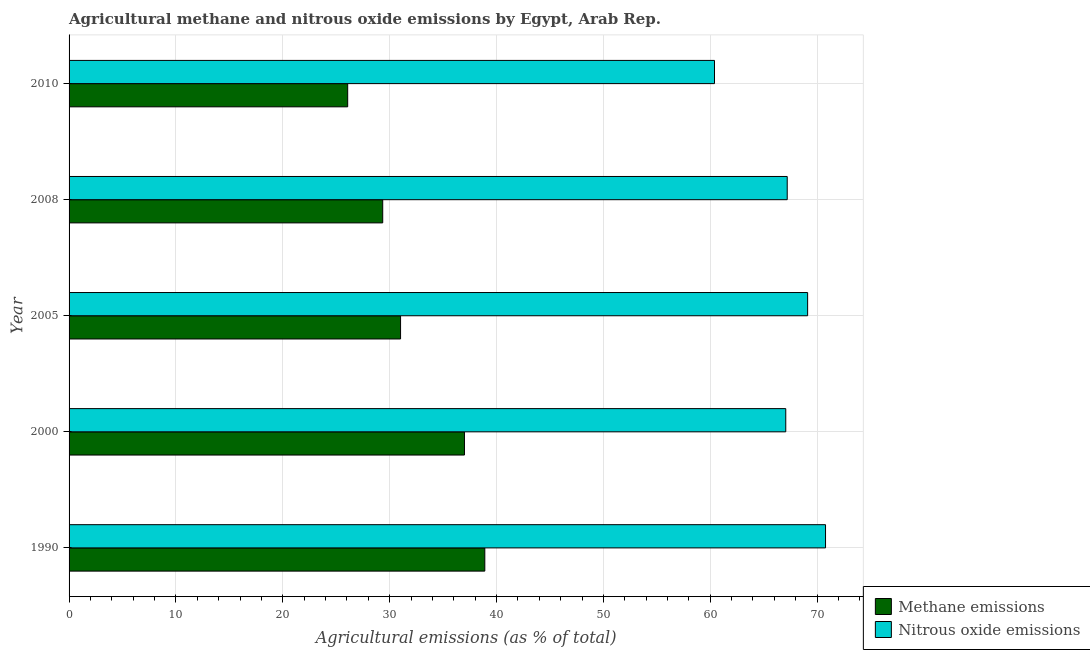How many bars are there on the 3rd tick from the top?
Give a very brief answer. 2. How many bars are there on the 5th tick from the bottom?
Provide a short and direct response. 2. What is the label of the 4th group of bars from the top?
Make the answer very short. 2000. In how many cases, is the number of bars for a given year not equal to the number of legend labels?
Your answer should be very brief. 0. What is the amount of methane emissions in 2000?
Offer a very short reply. 37. Across all years, what is the maximum amount of nitrous oxide emissions?
Ensure brevity in your answer.  70.79. Across all years, what is the minimum amount of methane emissions?
Your answer should be compact. 26.07. What is the total amount of nitrous oxide emissions in the graph?
Offer a terse response. 334.57. What is the difference between the amount of methane emissions in 2000 and that in 2005?
Your answer should be compact. 5.98. What is the difference between the amount of methane emissions in 2008 and the amount of nitrous oxide emissions in 1990?
Give a very brief answer. -41.44. What is the average amount of methane emissions per year?
Give a very brief answer. 32.47. In the year 1990, what is the difference between the amount of nitrous oxide emissions and amount of methane emissions?
Your response must be concise. 31.88. In how many years, is the amount of nitrous oxide emissions greater than 60 %?
Your answer should be compact. 5. Is the amount of nitrous oxide emissions in 2000 less than that in 2008?
Your answer should be very brief. Yes. Is the difference between the amount of nitrous oxide emissions in 2000 and 2005 greater than the difference between the amount of methane emissions in 2000 and 2005?
Your response must be concise. No. What is the difference between the highest and the second highest amount of nitrous oxide emissions?
Your response must be concise. 1.68. What is the difference between the highest and the lowest amount of methane emissions?
Keep it short and to the point. 12.83. What does the 2nd bar from the top in 1990 represents?
Provide a short and direct response. Methane emissions. What does the 1st bar from the bottom in 2000 represents?
Offer a very short reply. Methane emissions. How many bars are there?
Your response must be concise. 10. How many years are there in the graph?
Keep it short and to the point. 5. What is the difference between two consecutive major ticks on the X-axis?
Your response must be concise. 10. Are the values on the major ticks of X-axis written in scientific E-notation?
Offer a very short reply. No. How many legend labels are there?
Provide a short and direct response. 2. What is the title of the graph?
Offer a very short reply. Agricultural methane and nitrous oxide emissions by Egypt, Arab Rep. What is the label or title of the X-axis?
Your response must be concise. Agricultural emissions (as % of total). What is the label or title of the Y-axis?
Ensure brevity in your answer.  Year. What is the Agricultural emissions (as % of total) in Methane emissions in 1990?
Your answer should be compact. 38.9. What is the Agricultural emissions (as % of total) of Nitrous oxide emissions in 1990?
Provide a short and direct response. 70.79. What is the Agricultural emissions (as % of total) of Methane emissions in 2000?
Give a very brief answer. 37. What is the Agricultural emissions (as % of total) in Nitrous oxide emissions in 2000?
Provide a short and direct response. 67.07. What is the Agricultural emissions (as % of total) of Methane emissions in 2005?
Offer a very short reply. 31.02. What is the Agricultural emissions (as % of total) in Nitrous oxide emissions in 2005?
Offer a very short reply. 69.11. What is the Agricultural emissions (as % of total) of Methane emissions in 2008?
Give a very brief answer. 29.35. What is the Agricultural emissions (as % of total) of Nitrous oxide emissions in 2008?
Your response must be concise. 67.2. What is the Agricultural emissions (as % of total) of Methane emissions in 2010?
Provide a short and direct response. 26.07. What is the Agricultural emissions (as % of total) in Nitrous oxide emissions in 2010?
Give a very brief answer. 60.4. Across all years, what is the maximum Agricultural emissions (as % of total) of Methane emissions?
Keep it short and to the point. 38.9. Across all years, what is the maximum Agricultural emissions (as % of total) in Nitrous oxide emissions?
Your answer should be very brief. 70.79. Across all years, what is the minimum Agricultural emissions (as % of total) in Methane emissions?
Provide a short and direct response. 26.07. Across all years, what is the minimum Agricultural emissions (as % of total) of Nitrous oxide emissions?
Provide a succinct answer. 60.4. What is the total Agricultural emissions (as % of total) of Methane emissions in the graph?
Provide a short and direct response. 162.35. What is the total Agricultural emissions (as % of total) of Nitrous oxide emissions in the graph?
Keep it short and to the point. 334.57. What is the difference between the Agricultural emissions (as % of total) in Methane emissions in 1990 and that in 2000?
Keep it short and to the point. 1.9. What is the difference between the Agricultural emissions (as % of total) of Nitrous oxide emissions in 1990 and that in 2000?
Your response must be concise. 3.72. What is the difference between the Agricultural emissions (as % of total) of Methane emissions in 1990 and that in 2005?
Offer a terse response. 7.88. What is the difference between the Agricultural emissions (as % of total) of Nitrous oxide emissions in 1990 and that in 2005?
Keep it short and to the point. 1.68. What is the difference between the Agricultural emissions (as % of total) in Methane emissions in 1990 and that in 2008?
Ensure brevity in your answer.  9.55. What is the difference between the Agricultural emissions (as % of total) of Nitrous oxide emissions in 1990 and that in 2008?
Make the answer very short. 3.59. What is the difference between the Agricultural emissions (as % of total) in Methane emissions in 1990 and that in 2010?
Provide a short and direct response. 12.83. What is the difference between the Agricultural emissions (as % of total) of Nitrous oxide emissions in 1990 and that in 2010?
Your answer should be compact. 10.39. What is the difference between the Agricultural emissions (as % of total) of Methane emissions in 2000 and that in 2005?
Offer a terse response. 5.98. What is the difference between the Agricultural emissions (as % of total) of Nitrous oxide emissions in 2000 and that in 2005?
Offer a very short reply. -2.05. What is the difference between the Agricultural emissions (as % of total) of Methane emissions in 2000 and that in 2008?
Your response must be concise. 7.65. What is the difference between the Agricultural emissions (as % of total) of Nitrous oxide emissions in 2000 and that in 2008?
Make the answer very short. -0.14. What is the difference between the Agricultural emissions (as % of total) in Methane emissions in 2000 and that in 2010?
Make the answer very short. 10.93. What is the difference between the Agricultural emissions (as % of total) of Nitrous oxide emissions in 2000 and that in 2010?
Offer a very short reply. 6.67. What is the difference between the Agricultural emissions (as % of total) in Methane emissions in 2005 and that in 2008?
Offer a very short reply. 1.67. What is the difference between the Agricultural emissions (as % of total) of Nitrous oxide emissions in 2005 and that in 2008?
Your response must be concise. 1.91. What is the difference between the Agricultural emissions (as % of total) of Methane emissions in 2005 and that in 2010?
Provide a succinct answer. 4.95. What is the difference between the Agricultural emissions (as % of total) in Nitrous oxide emissions in 2005 and that in 2010?
Provide a short and direct response. 8.71. What is the difference between the Agricultural emissions (as % of total) in Methane emissions in 2008 and that in 2010?
Ensure brevity in your answer.  3.28. What is the difference between the Agricultural emissions (as % of total) of Nitrous oxide emissions in 2008 and that in 2010?
Your answer should be very brief. 6.8. What is the difference between the Agricultural emissions (as % of total) of Methane emissions in 1990 and the Agricultural emissions (as % of total) of Nitrous oxide emissions in 2000?
Keep it short and to the point. -28.16. What is the difference between the Agricultural emissions (as % of total) of Methane emissions in 1990 and the Agricultural emissions (as % of total) of Nitrous oxide emissions in 2005?
Provide a short and direct response. -30.21. What is the difference between the Agricultural emissions (as % of total) of Methane emissions in 1990 and the Agricultural emissions (as % of total) of Nitrous oxide emissions in 2008?
Provide a succinct answer. -28.3. What is the difference between the Agricultural emissions (as % of total) in Methane emissions in 1990 and the Agricultural emissions (as % of total) in Nitrous oxide emissions in 2010?
Make the answer very short. -21.49. What is the difference between the Agricultural emissions (as % of total) in Methane emissions in 2000 and the Agricultural emissions (as % of total) in Nitrous oxide emissions in 2005?
Provide a short and direct response. -32.11. What is the difference between the Agricultural emissions (as % of total) in Methane emissions in 2000 and the Agricultural emissions (as % of total) in Nitrous oxide emissions in 2008?
Offer a very short reply. -30.2. What is the difference between the Agricultural emissions (as % of total) of Methane emissions in 2000 and the Agricultural emissions (as % of total) of Nitrous oxide emissions in 2010?
Offer a very short reply. -23.4. What is the difference between the Agricultural emissions (as % of total) of Methane emissions in 2005 and the Agricultural emissions (as % of total) of Nitrous oxide emissions in 2008?
Give a very brief answer. -36.18. What is the difference between the Agricultural emissions (as % of total) in Methane emissions in 2005 and the Agricultural emissions (as % of total) in Nitrous oxide emissions in 2010?
Provide a succinct answer. -29.38. What is the difference between the Agricultural emissions (as % of total) of Methane emissions in 2008 and the Agricultural emissions (as % of total) of Nitrous oxide emissions in 2010?
Your response must be concise. -31.05. What is the average Agricultural emissions (as % of total) of Methane emissions per year?
Keep it short and to the point. 32.47. What is the average Agricultural emissions (as % of total) of Nitrous oxide emissions per year?
Give a very brief answer. 66.91. In the year 1990, what is the difference between the Agricultural emissions (as % of total) in Methane emissions and Agricultural emissions (as % of total) in Nitrous oxide emissions?
Make the answer very short. -31.88. In the year 2000, what is the difference between the Agricultural emissions (as % of total) in Methane emissions and Agricultural emissions (as % of total) in Nitrous oxide emissions?
Give a very brief answer. -30.07. In the year 2005, what is the difference between the Agricultural emissions (as % of total) in Methane emissions and Agricultural emissions (as % of total) in Nitrous oxide emissions?
Ensure brevity in your answer.  -38.09. In the year 2008, what is the difference between the Agricultural emissions (as % of total) of Methane emissions and Agricultural emissions (as % of total) of Nitrous oxide emissions?
Provide a succinct answer. -37.85. In the year 2010, what is the difference between the Agricultural emissions (as % of total) in Methane emissions and Agricultural emissions (as % of total) in Nitrous oxide emissions?
Make the answer very short. -34.33. What is the ratio of the Agricultural emissions (as % of total) in Methane emissions in 1990 to that in 2000?
Offer a very short reply. 1.05. What is the ratio of the Agricultural emissions (as % of total) in Nitrous oxide emissions in 1990 to that in 2000?
Give a very brief answer. 1.06. What is the ratio of the Agricultural emissions (as % of total) in Methane emissions in 1990 to that in 2005?
Keep it short and to the point. 1.25. What is the ratio of the Agricultural emissions (as % of total) in Nitrous oxide emissions in 1990 to that in 2005?
Provide a succinct answer. 1.02. What is the ratio of the Agricultural emissions (as % of total) in Methane emissions in 1990 to that in 2008?
Your answer should be compact. 1.33. What is the ratio of the Agricultural emissions (as % of total) in Nitrous oxide emissions in 1990 to that in 2008?
Keep it short and to the point. 1.05. What is the ratio of the Agricultural emissions (as % of total) of Methane emissions in 1990 to that in 2010?
Keep it short and to the point. 1.49. What is the ratio of the Agricultural emissions (as % of total) of Nitrous oxide emissions in 1990 to that in 2010?
Make the answer very short. 1.17. What is the ratio of the Agricultural emissions (as % of total) in Methane emissions in 2000 to that in 2005?
Provide a succinct answer. 1.19. What is the ratio of the Agricultural emissions (as % of total) in Nitrous oxide emissions in 2000 to that in 2005?
Keep it short and to the point. 0.97. What is the ratio of the Agricultural emissions (as % of total) in Methane emissions in 2000 to that in 2008?
Make the answer very short. 1.26. What is the ratio of the Agricultural emissions (as % of total) of Nitrous oxide emissions in 2000 to that in 2008?
Give a very brief answer. 1. What is the ratio of the Agricultural emissions (as % of total) in Methane emissions in 2000 to that in 2010?
Offer a very short reply. 1.42. What is the ratio of the Agricultural emissions (as % of total) of Nitrous oxide emissions in 2000 to that in 2010?
Offer a very short reply. 1.11. What is the ratio of the Agricultural emissions (as % of total) of Methane emissions in 2005 to that in 2008?
Provide a short and direct response. 1.06. What is the ratio of the Agricultural emissions (as % of total) in Nitrous oxide emissions in 2005 to that in 2008?
Offer a terse response. 1.03. What is the ratio of the Agricultural emissions (as % of total) in Methane emissions in 2005 to that in 2010?
Your answer should be compact. 1.19. What is the ratio of the Agricultural emissions (as % of total) of Nitrous oxide emissions in 2005 to that in 2010?
Ensure brevity in your answer.  1.14. What is the ratio of the Agricultural emissions (as % of total) in Methane emissions in 2008 to that in 2010?
Keep it short and to the point. 1.13. What is the ratio of the Agricultural emissions (as % of total) in Nitrous oxide emissions in 2008 to that in 2010?
Offer a very short reply. 1.11. What is the difference between the highest and the second highest Agricultural emissions (as % of total) in Methane emissions?
Your answer should be compact. 1.9. What is the difference between the highest and the second highest Agricultural emissions (as % of total) in Nitrous oxide emissions?
Provide a short and direct response. 1.68. What is the difference between the highest and the lowest Agricultural emissions (as % of total) of Methane emissions?
Offer a very short reply. 12.83. What is the difference between the highest and the lowest Agricultural emissions (as % of total) of Nitrous oxide emissions?
Provide a short and direct response. 10.39. 